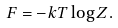Convert formula to latex. <formula><loc_0><loc_0><loc_500><loc_500>F = - k T \log Z .</formula> 